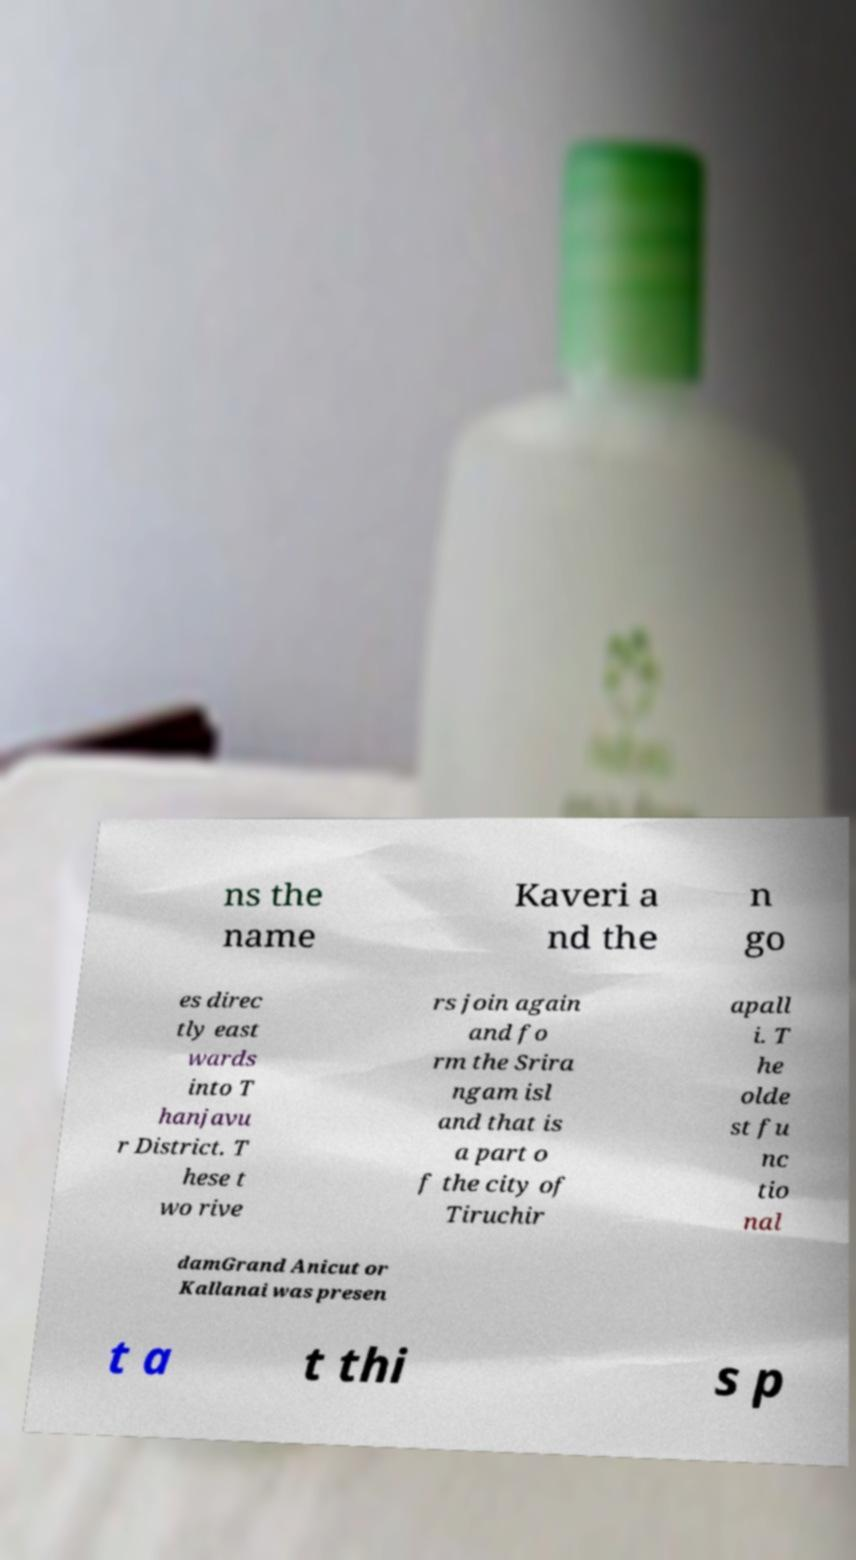For documentation purposes, I need the text within this image transcribed. Could you provide that? ns the name Kaveri a nd the n go es direc tly east wards into T hanjavu r District. T hese t wo rive rs join again and fo rm the Srira ngam isl and that is a part o f the city of Tiruchir apall i. T he olde st fu nc tio nal damGrand Anicut or Kallanai was presen t a t thi s p 